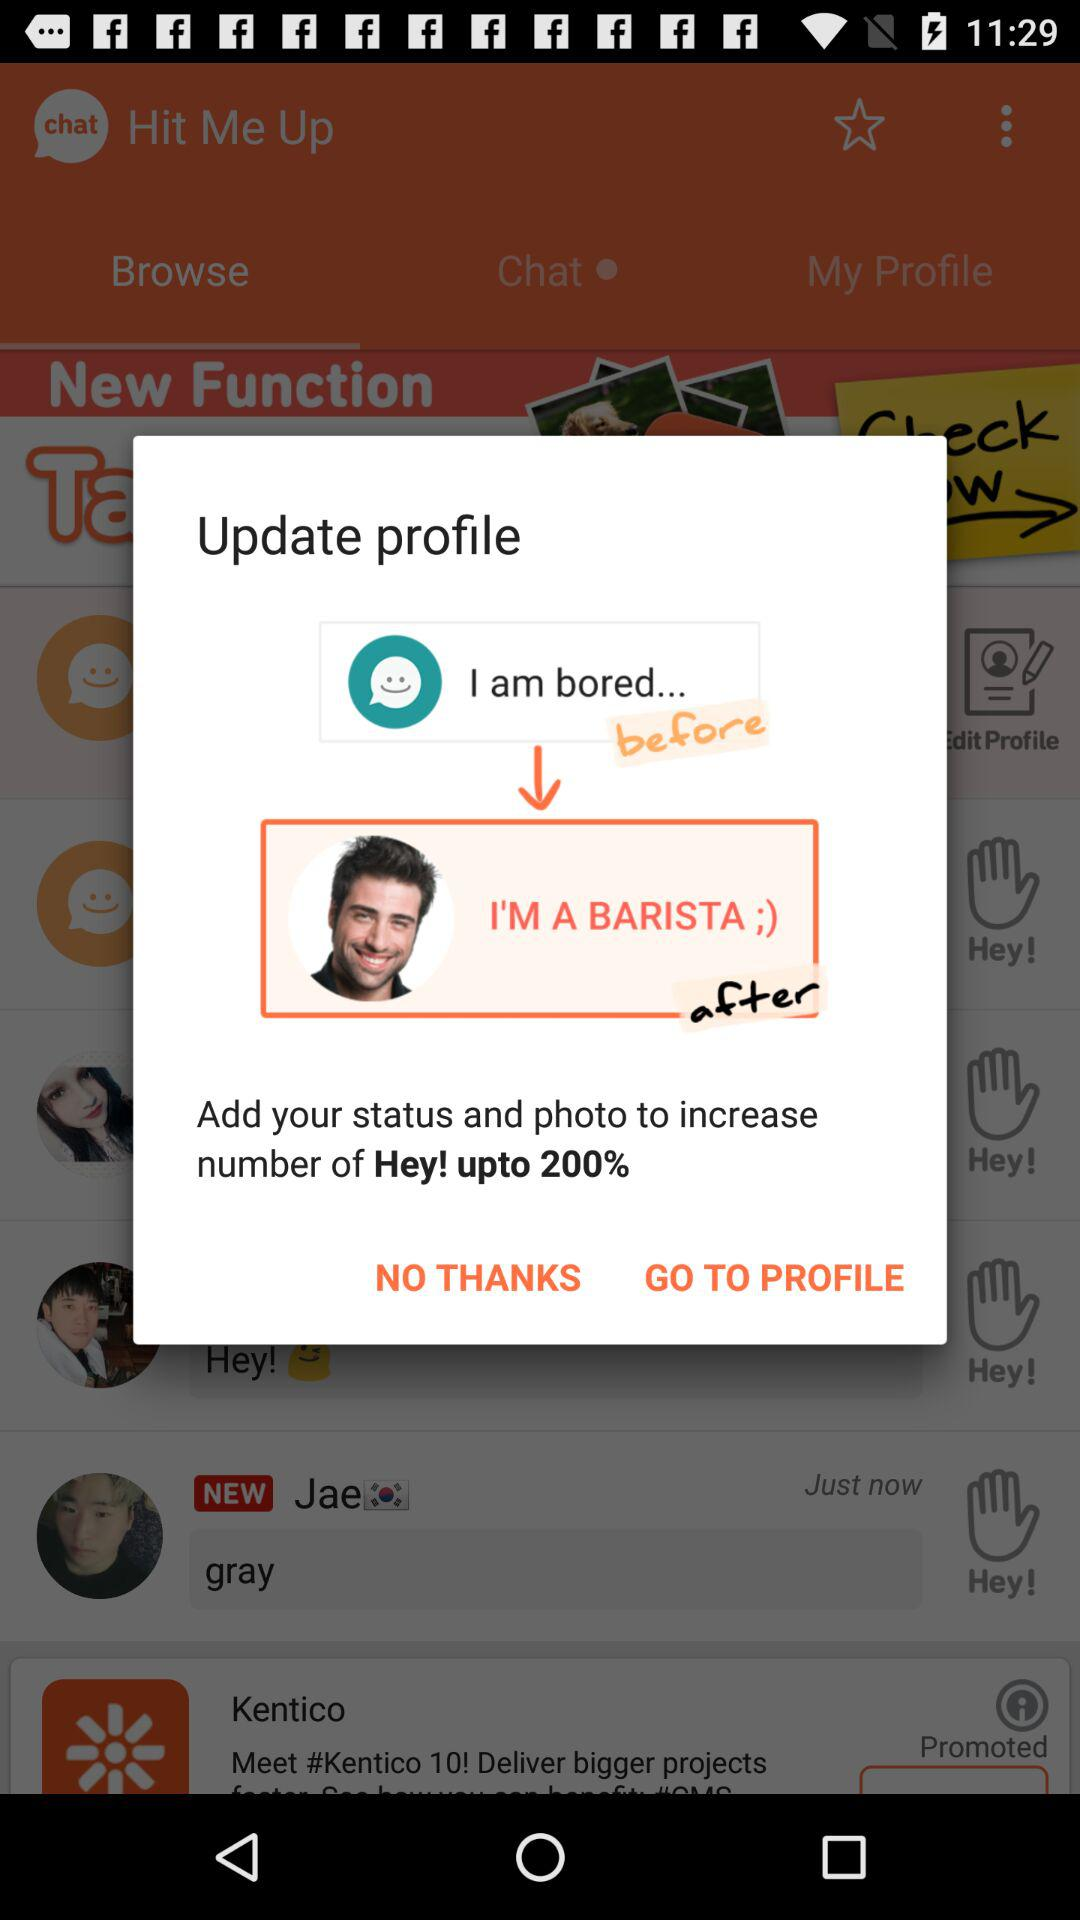How many more Heys will you get if you update your status and photo?
Answer the question using a single word or phrase. 200% 